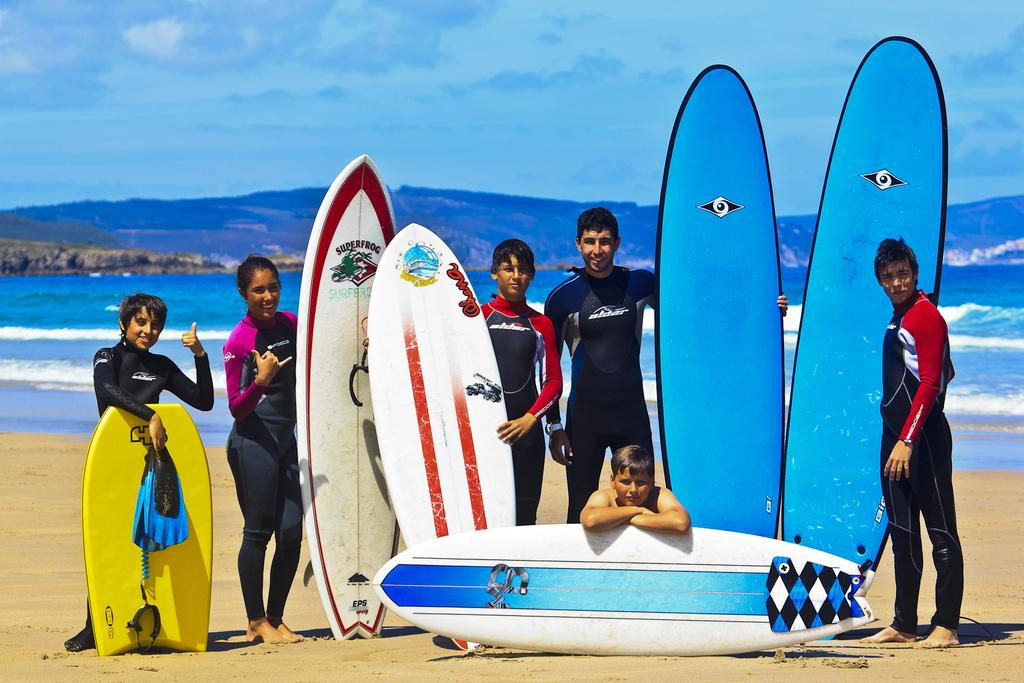Who or what can be seen in the image? There are people in the image. Where are the people located in the image? The people are standing near the sea shore. What are the people holding in the image? The people are holding surfing boards. What type of water body is visible in the image? There is an ocean visible in the image. What is the condition of the sky in the image? The sky is clear in the image. Is there any evidence of an expansion project in the image? There is no mention or indication of an expansion project in the image. Can you provide a statement about the volcanic activity in the image? There is no volcanic activity present in the image; it features people near the sea shore with surfing boards. 